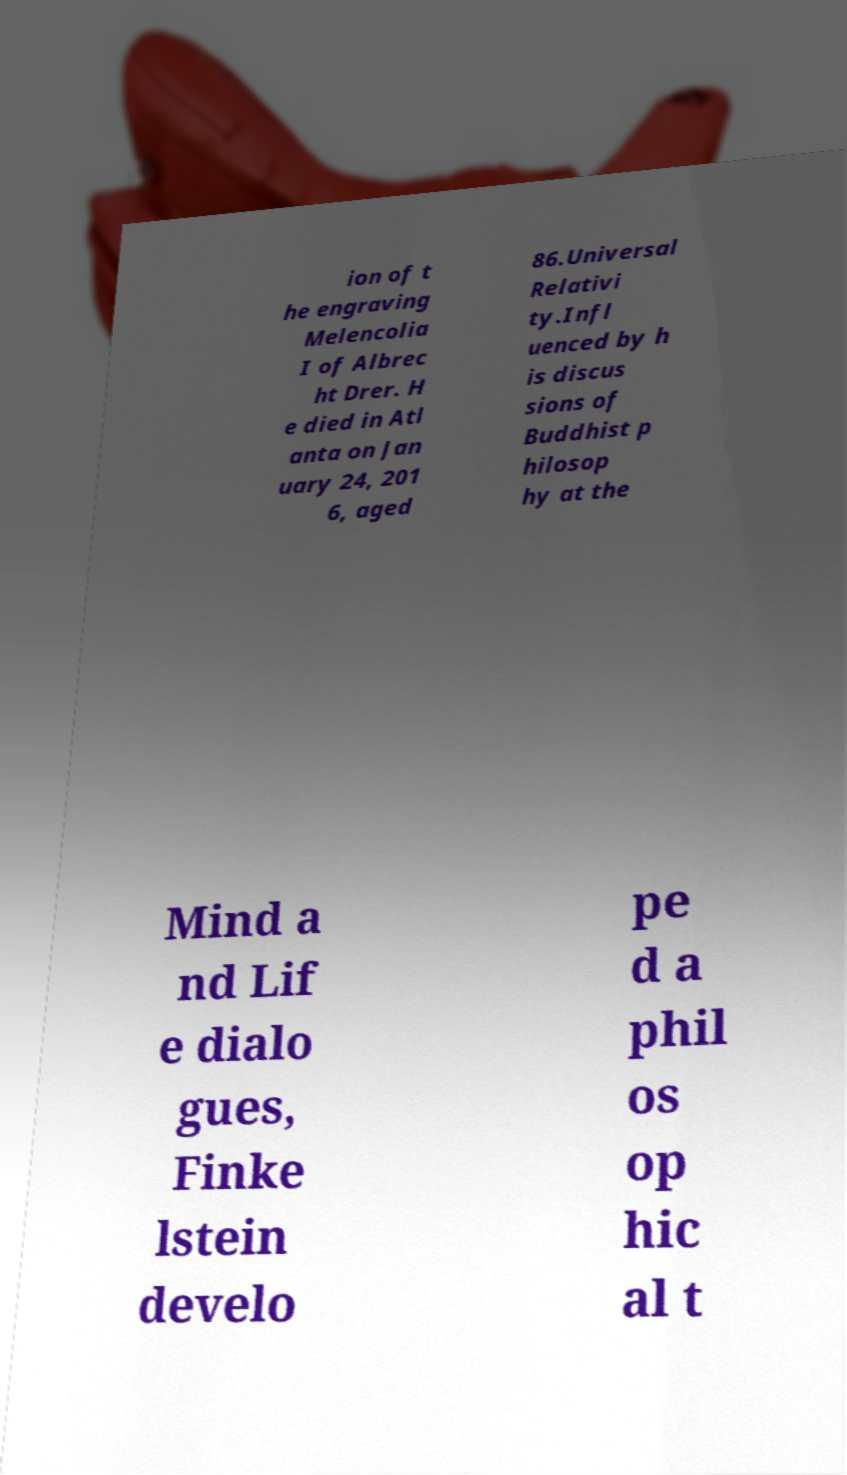Could you extract and type out the text from this image? ion of t he engraving Melencolia I of Albrec ht Drer. H e died in Atl anta on Jan uary 24, 201 6, aged 86.Universal Relativi ty.Infl uenced by h is discus sions of Buddhist p hilosop hy at the Mind a nd Lif e dialo gues, Finke lstein develo pe d a phil os op hic al t 